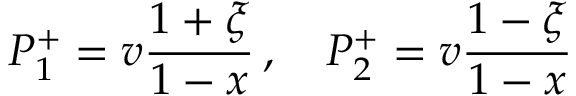<formula> <loc_0><loc_0><loc_500><loc_500>P _ { 1 } ^ { + } = v \frac { 1 + \xi } { 1 - x } \, , \quad P _ { 2 } ^ { + } = v \frac { 1 - \xi } { 1 - x }</formula> 